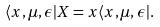<formula> <loc_0><loc_0><loc_500><loc_500>\langle x , \mu , \epsilon | X = x \langle x , \mu , \epsilon | .</formula> 